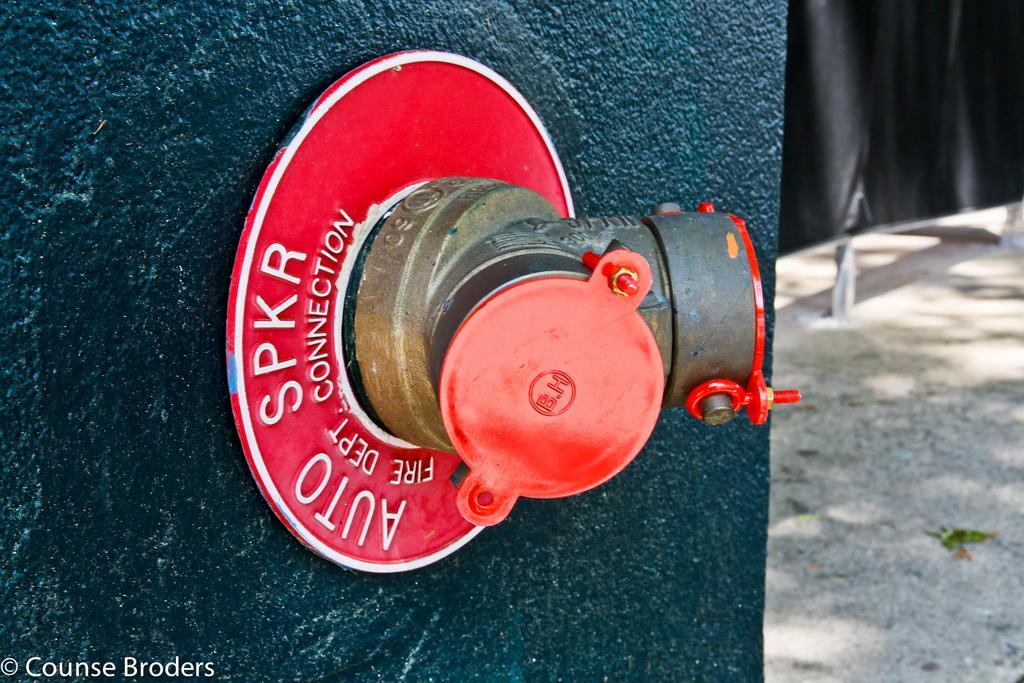Can you describe this image briefly? In this picture we can see a metal pipe with lids on the wall and in the background we can see the ground. 